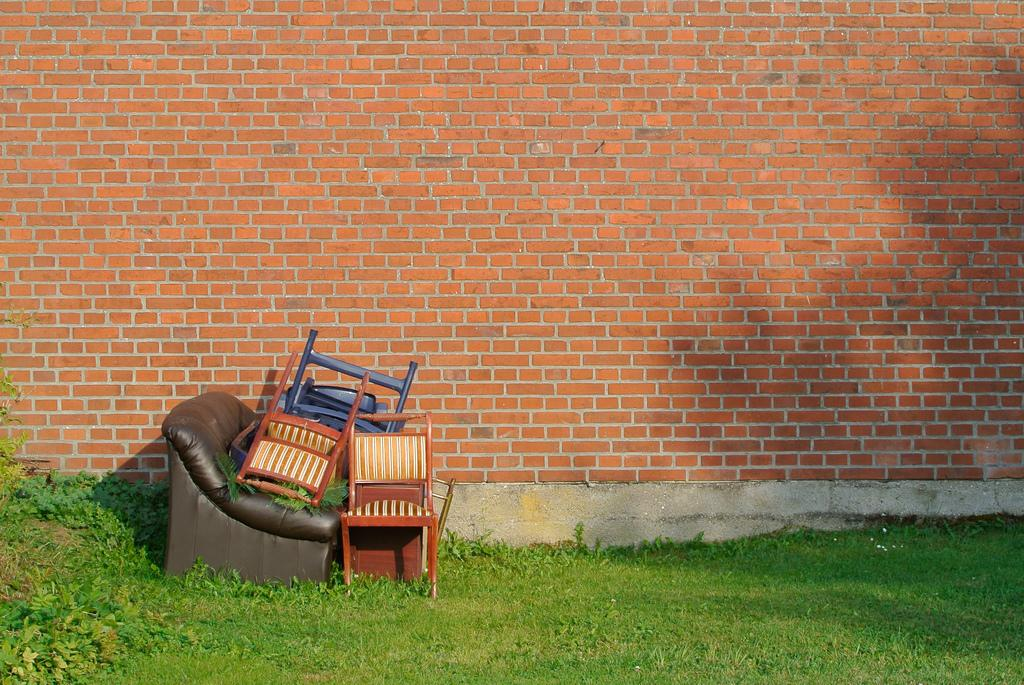What type of objects are on the ground in the image? There are chairs and other objects on the ground in the image. What type of natural environment is visible in the image? There is grass visible in the image. What type of vegetation is present in the image? There are plants in the image. What can be seen in the background of the image? There is a wall in the background of the image. What type of record can be seen being played on the wall in the image? There is no record or any indication of music playing in the image. The wall in the background is just a plain wall with no additional details. 